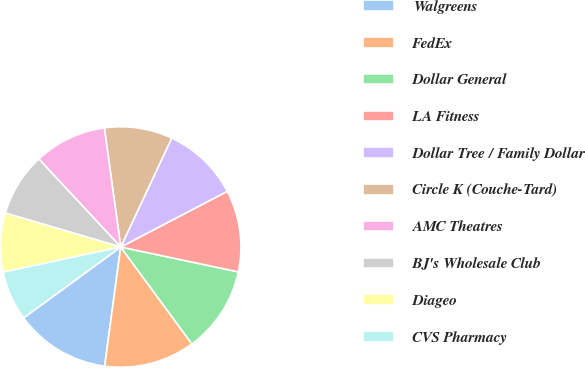<chart> <loc_0><loc_0><loc_500><loc_500><pie_chart><fcel>Walgreens<fcel>FedEx<fcel>Dollar General<fcel>LA Fitness<fcel>Dollar Tree / Family Dollar<fcel>Circle K (Couche-Tard)<fcel>AMC Theatres<fcel>BJ's Wholesale Club<fcel>Diageo<fcel>CVS Pharmacy<nl><fcel>12.83%<fcel>12.21%<fcel>11.6%<fcel>10.98%<fcel>10.37%<fcel>9.14%<fcel>9.75%<fcel>8.52%<fcel>7.91%<fcel>6.68%<nl></chart> 